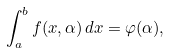Convert formula to latex. <formula><loc_0><loc_0><loc_500><loc_500>\int _ { a } ^ { b } f ( x , \alpha ) \, d x = \varphi ( \alpha ) ,</formula> 